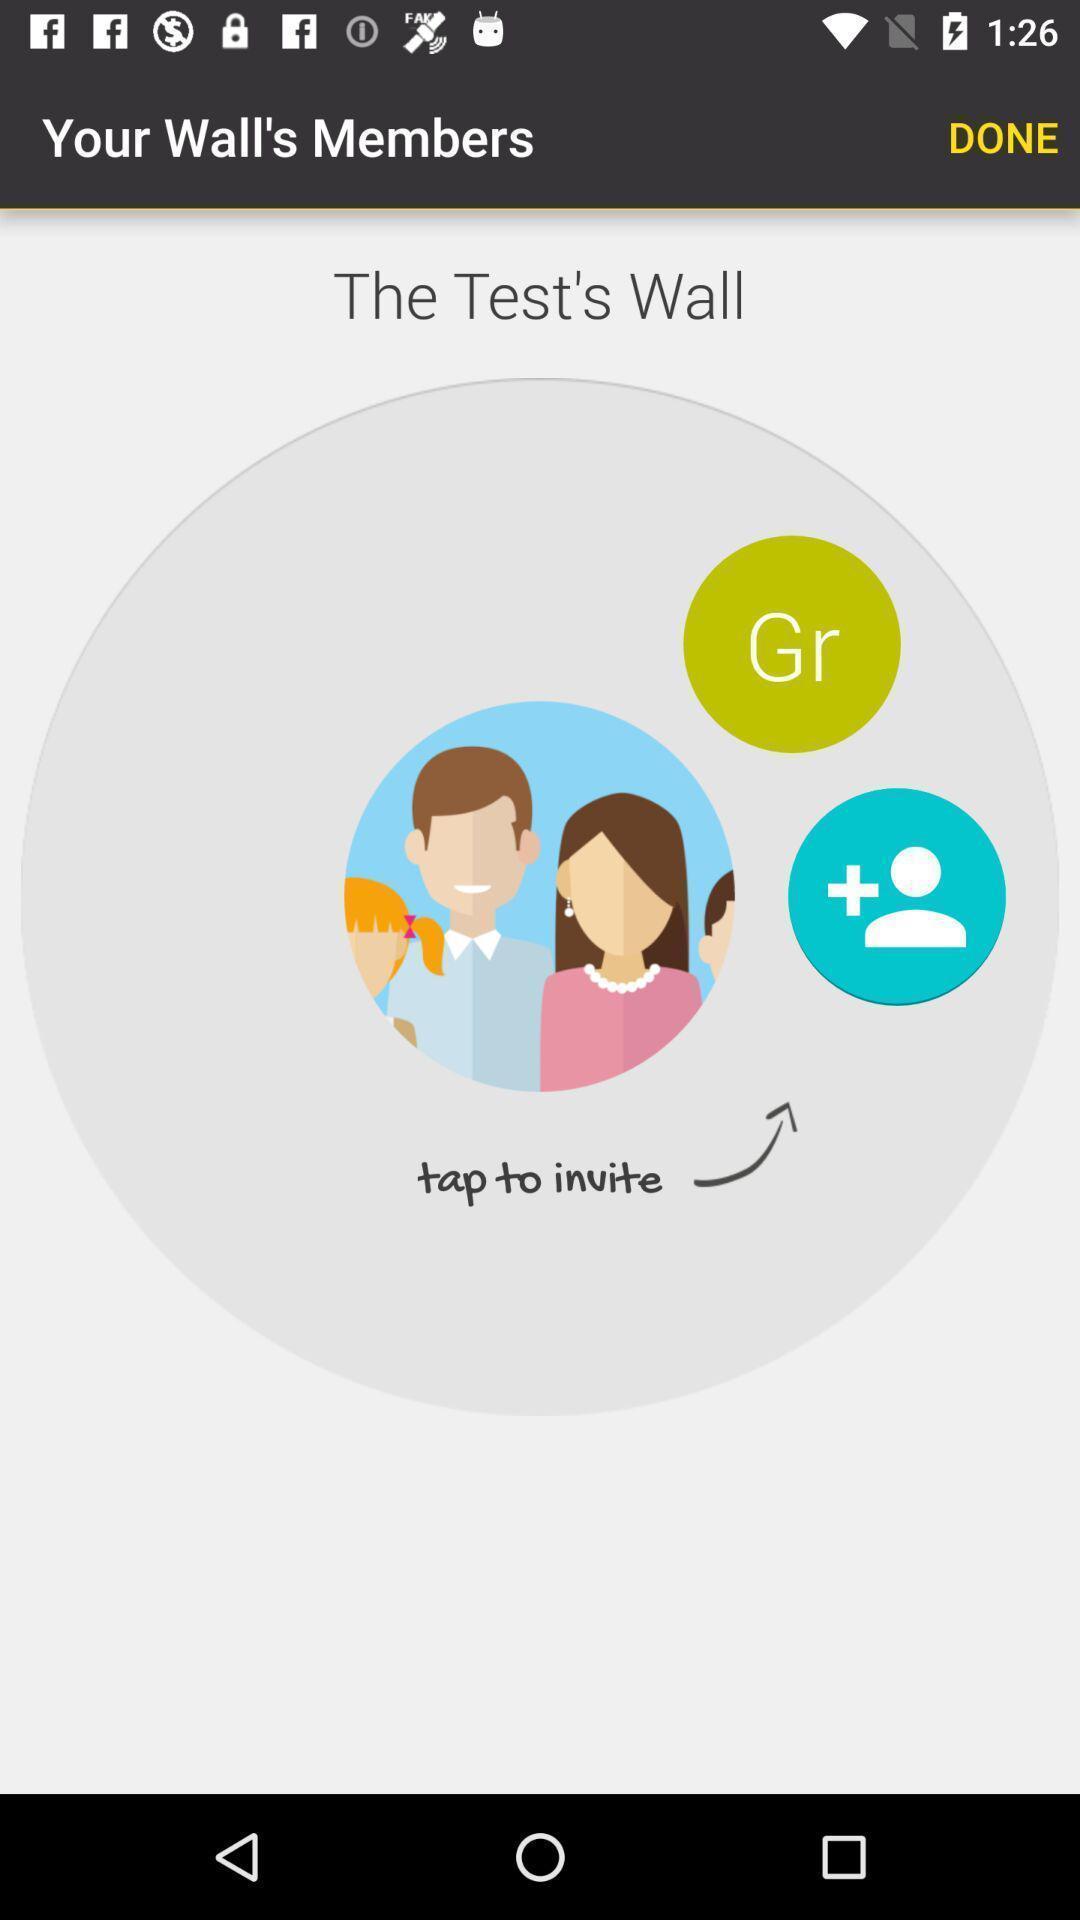Describe the content in this image. Test wall of walls members. 